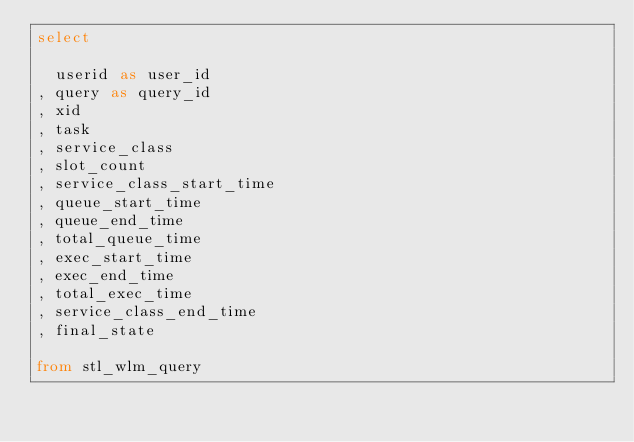<code> <loc_0><loc_0><loc_500><loc_500><_SQL_>select

  userid as user_id
, query as query_id
, xid
, task
, service_class
, slot_count
, service_class_start_time
, queue_start_time
, queue_end_time
, total_queue_time
, exec_start_time
, exec_end_time
, total_exec_time
, service_class_end_time
, final_state

from stl_wlm_query
</code> 